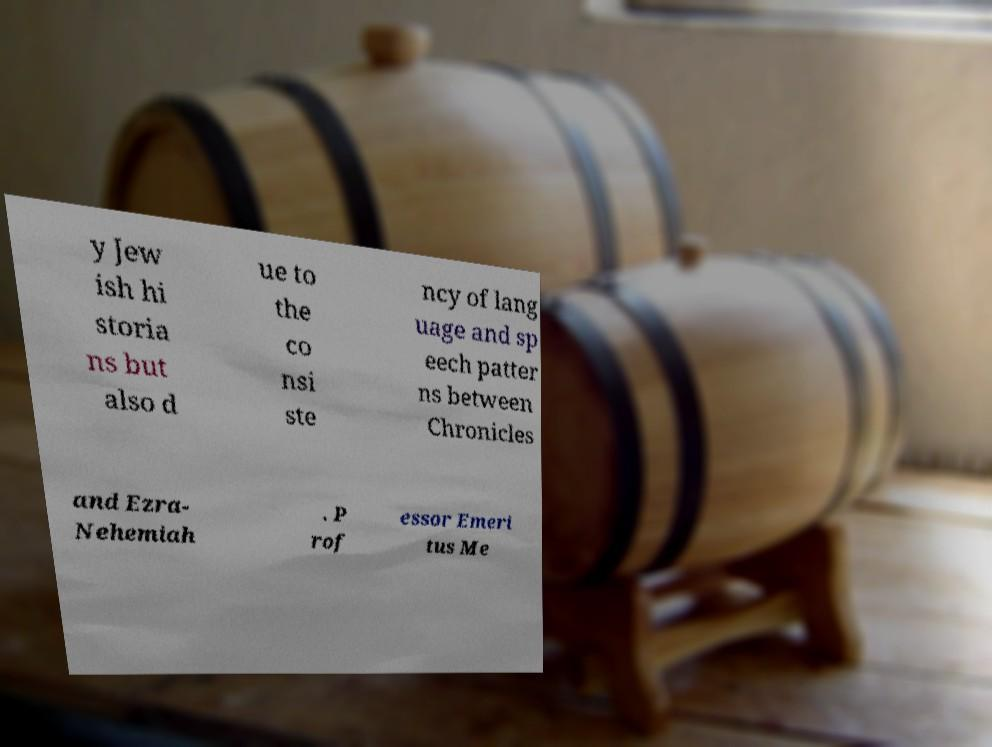For documentation purposes, I need the text within this image transcribed. Could you provide that? y Jew ish hi storia ns but also d ue to the co nsi ste ncy of lang uage and sp eech patter ns between Chronicles and Ezra- Nehemiah . P rof essor Emeri tus Me 